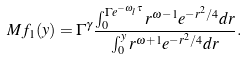<formula> <loc_0><loc_0><loc_500><loc_500>M f _ { 1 } ( y ) = \Gamma ^ { \gamma } \frac { \int _ { 0 } ^ { \Gamma e ^ { - \omega _ { l } \tau } } r ^ { \omega - 1 } e ^ { - r ^ { 2 } / 4 } d r } { \int _ { 0 } ^ { y } r ^ { \omega + 1 } e ^ { - r ^ { 2 } / 4 } d r } .</formula> 